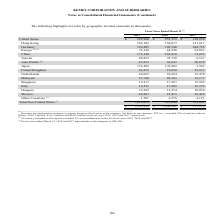From Kemet Corporation's financial document, Which years does the table provide information for net sales by geographic location? The document contains multiple relevant values: 2019, 2018, 2017. From the document: "2019 2018 2017 2019 2018 2017 2019 2018 2017..." Also, What was the net sales in Hong Kong in 2018? According to the financial document, 169,073 (in thousands). The relevant text states: "Hong Kong 188,102 169,073 121,813..." Also, What was the net sales in Singapore in 2017? According to the financial document, 15,565 (in thousands). The relevant text states: "Singapore 19,417 17,267 15,565..." Also, can you calculate: What was the change in net sales in Mexico between 2017 and 2018? Based on the calculation: 23,915-22,424, the result is 1491 (in thousands). This is based on the information: "Mexico 44,267 23,915 22,424 Mexico 44,267 23,915 22,424..." The key data points involved are: 22,424, 23,915. Additionally, Which years did the total net sales in all regions exceed $1,000,000 thousand? The document shows two values: 2019 and 2018. From the document: "2019 2018 2017 2019 2018 2017..." Also, can you calculate: What was the percentage change in the net sales from Other Countries between 2018 and 2019? To answer this question, I need to perform calculations using the financial data. The calculation is: (1,281-2,278)/2,278, which equals -43.77 (percentage). This is based on the information: "Other Countries (2) 1,281 2,278 4,131 Other Countries (2) 1,281 2,278 4,131..." The key data points involved are: 1,281, 2,278. 